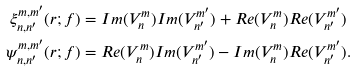<formula> <loc_0><loc_0><loc_500><loc_500>\xi _ { n , n ^ { \prime } } ^ { m , m ^ { \prime } } ( r ; f ) & = I m ( V _ { n } ^ { m } ) I m ( V _ { n ^ { \prime } } ^ { m ^ { \prime } } ) + R e ( V _ { n } ^ { m } ) R e ( V _ { n ^ { \prime } } ^ { m ^ { \prime } } ) \\ \psi _ { n , n ^ { \prime } } ^ { m , m ^ { \prime } } ( r ; f ) & = R e ( V _ { n } ^ { m } ) I m ( V _ { n ^ { \prime } } ^ { m ^ { \prime } } ) - I m ( V _ { n } ^ { m } ) R e ( V _ { n ^ { \prime } } ^ { m ^ { \prime } } ) .</formula> 